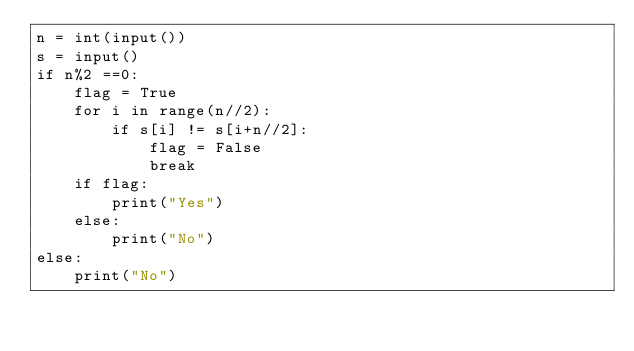<code> <loc_0><loc_0><loc_500><loc_500><_Python_>n = int(input())
s = input()
if n%2 ==0:
    flag = True
    for i in range(n//2):
        if s[i] != s[i+n//2]:
            flag = False
            break
    if flag:
        print("Yes")
    else:
        print("No")
else:
    print("No")</code> 